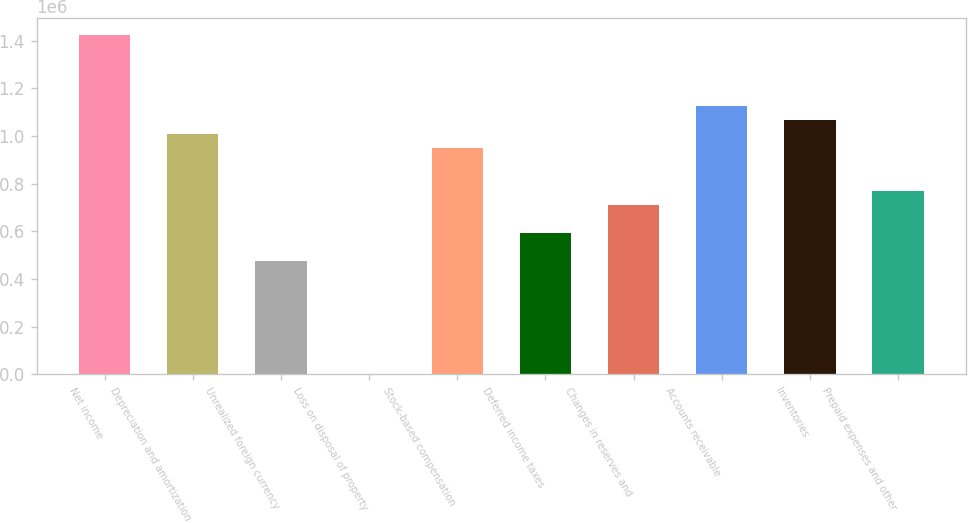Convert chart. <chart><loc_0><loc_0><loc_500><loc_500><bar_chart><fcel>Net income<fcel>Depreciation and amortization<fcel>Unrealized foreign currency<fcel>Loss on disposal of property<fcel>Stock-based compensation<fcel>Deferred income taxes<fcel>Changes in reserves and<fcel>Accounts receivable<fcel>Inventories<fcel>Prepaid expenses and other<nl><fcel>1.42325e+06<fcel>1.00821e+06<fcel>474592<fcel>261<fcel>948923<fcel>593175<fcel>711758<fcel>1.1268e+06<fcel>1.06751e+06<fcel>771049<nl></chart> 